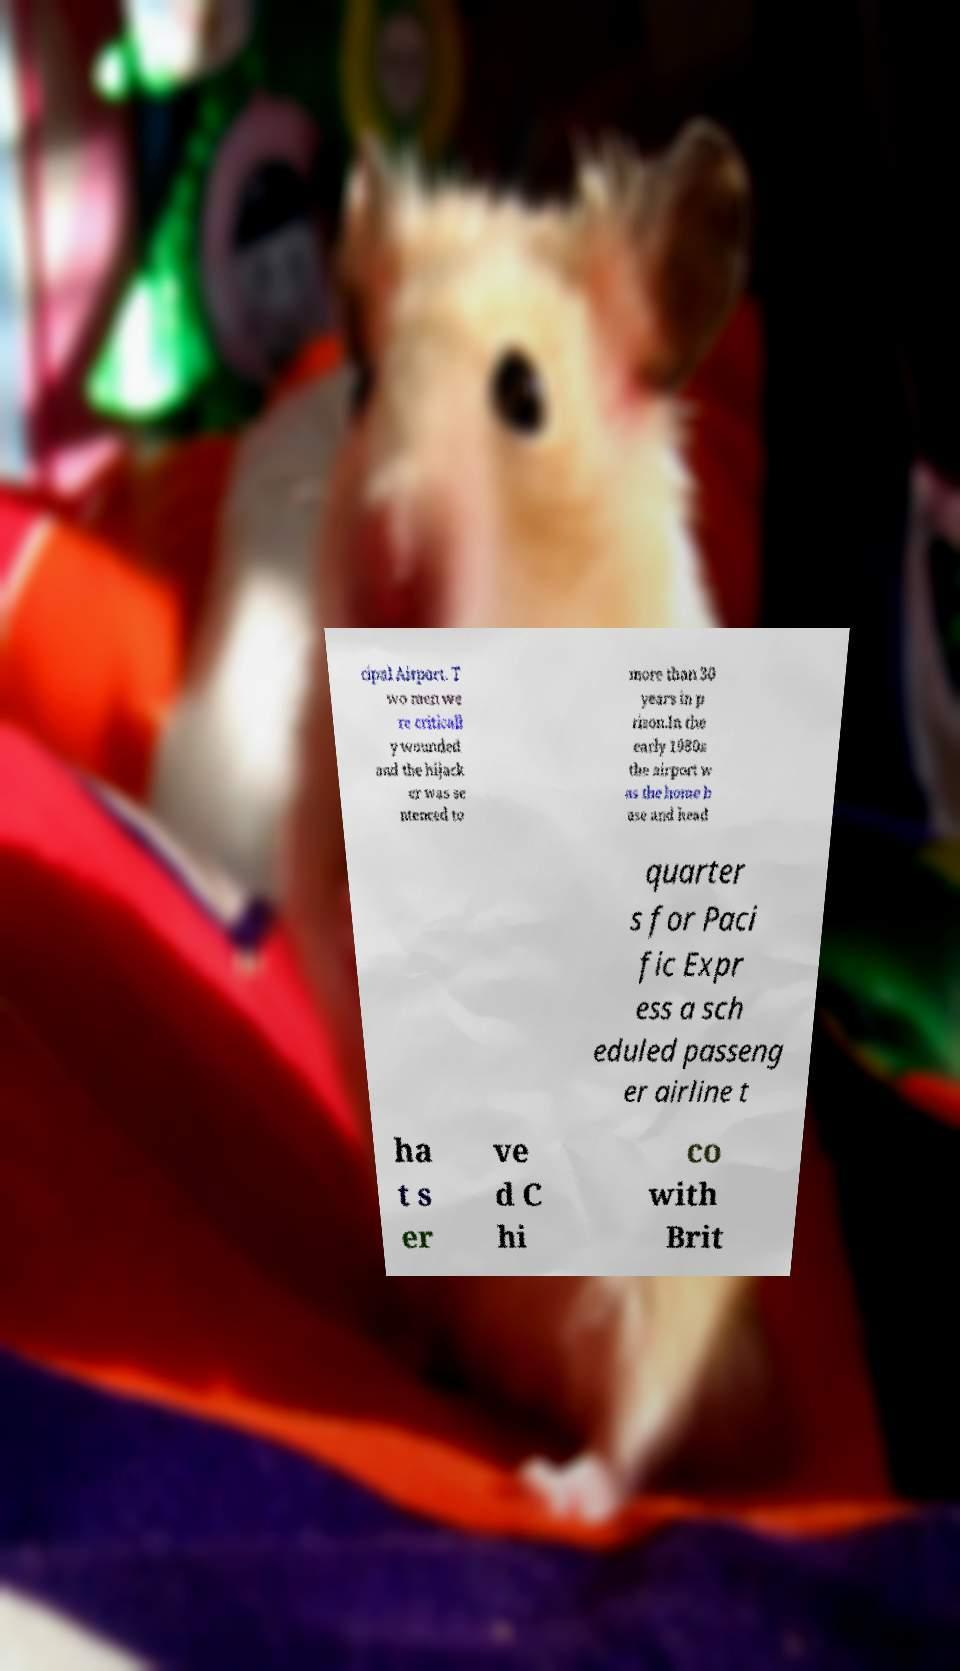Please read and relay the text visible in this image. What does it say? cipal Airport. T wo men we re criticall y wounded and the hijack er was se ntenced to more than 30 years in p rison.In the early 1980s the airport w as the home b ase and head quarter s for Paci fic Expr ess a sch eduled passeng er airline t ha t s er ve d C hi co with Brit 